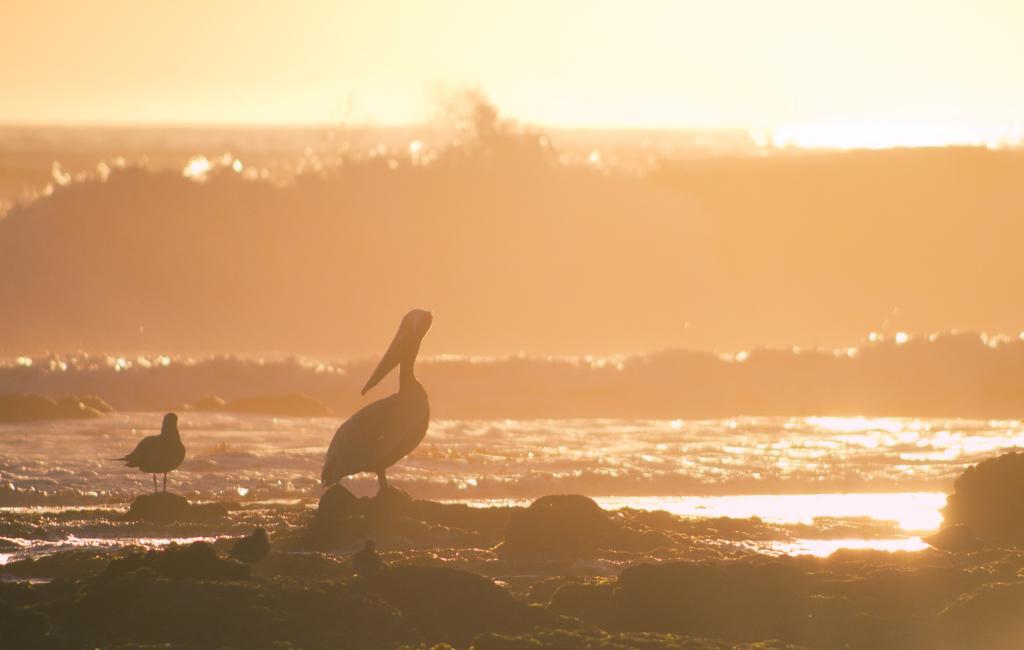How would you summarize this image in a sentence or two? In this image there are birds on the stones and there are waves in the water. 